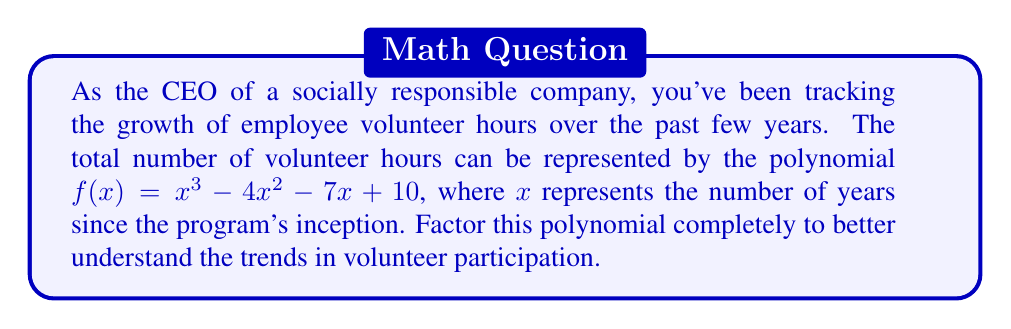Help me with this question. To factor this polynomial, we'll follow these steps:

1) First, check if there are any rational roots using the rational root theorem. The possible rational roots are the factors of the constant term (10): ±1, ±2, ±5, ±10.

2) Test these values in the polynomial. We find that $f(1) = 0$, so $(x-1)$ is a factor.

3) Divide the polynomial by $(x-1)$ using polynomial long division:

   $$\frac{x^3 - 4x^2 - 7x + 10}{x - 1} = x^2 - 3x - 10$$

4) Now we need to factor the quadratic $x^2 - 3x - 10$. We can do this by finding two numbers that multiply to give -10 and add to give -3. These numbers are -5 and 2.

5) Therefore, $x^2 - 3x - 10 = (x-5)(x+2)$

6) Combining all factors, we get:

   $$f(x) = (x-1)(x-5)(x+2)$$

This factorization reveals that the volunteer hours have three potential "zero growth" points: after 1 year, 5 years, and -2 years (which is not meaningful in this context but is mathematically correct).
Answer: $(x-1)(x-5)(x+2)$ 